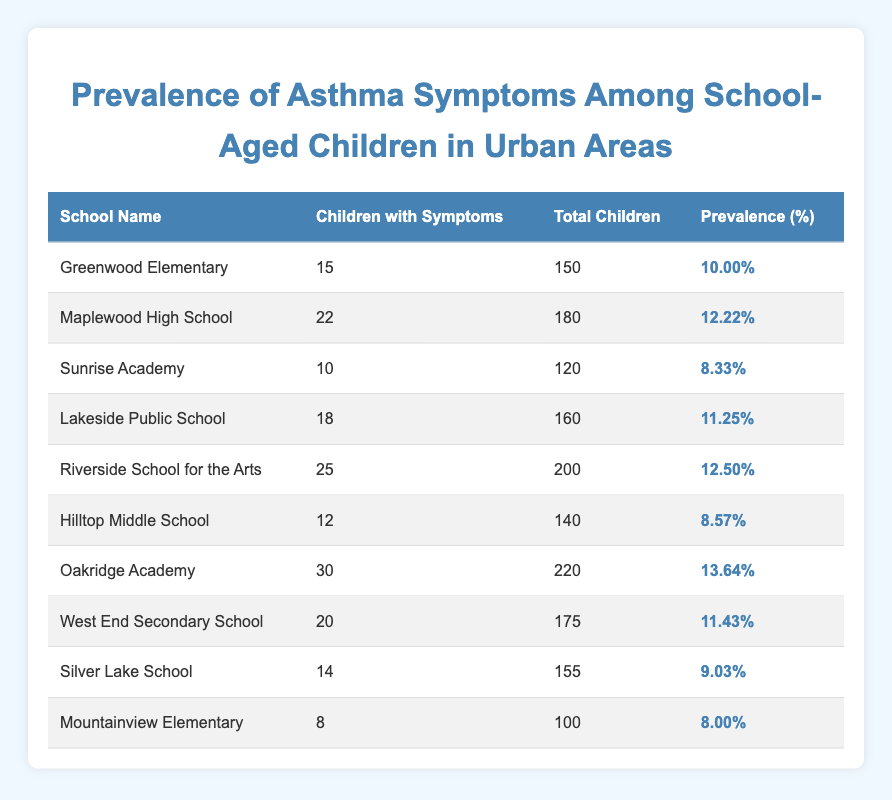What is the prevalence of asthma symptoms at Oakridge Academy? The table indicates that Oakridge Academy has 30 children with symptoms out of a total of 220 children. To calculate the prevalence, we use the formula (children with symptoms/total children) * 100, which equals (30/220) * 100 = 13.64%.
Answer: 13.64% Which school has the highest number of children with asthma symptoms? Looking at the table, Riverside School for the Arts has 25 children with symptoms, which is the highest number compared to other schools listed.
Answer: Riverside School for the Arts What is the average prevalence of asthma symptoms across all schools? To find the average prevalence, first, we calculate the prevalence for each school and then find the average. The prevalence percentages are: 10.00%, 12.22%, 8.33%, 11.25%, 12.50%, 8.57%, 13.64%, 11.43%, 9.03%, and 8.00%. Summing these gives 104.47%, and dividing by 10 (the number of schools) results in an average prevalence of 10.447%.
Answer: 10.45% Is it true that Mountainview Elementary has a higher prevalence of asthma symptoms than Sunrise Academy? Mountainview Elementary has a prevalence of 8.00%, while Sunrise Academy has a prevalence of 8.33%. Since 8.33% is greater than 8.00%, it is false that Mountainview Elementary has a higher prevalence.
Answer: No What is the total number of children with asthma symptoms across all schools? By adding the number of children with symptoms from each school (15 + 22 + 10 + 18 + 25 + 12 + 30 + 20 + 14 + 8), the total comes to  15 + 22 + 10 + 18 + 25 + 12 + 30 + 20 + 14 + 8 =  164 children with symptoms.
Answer: 164 